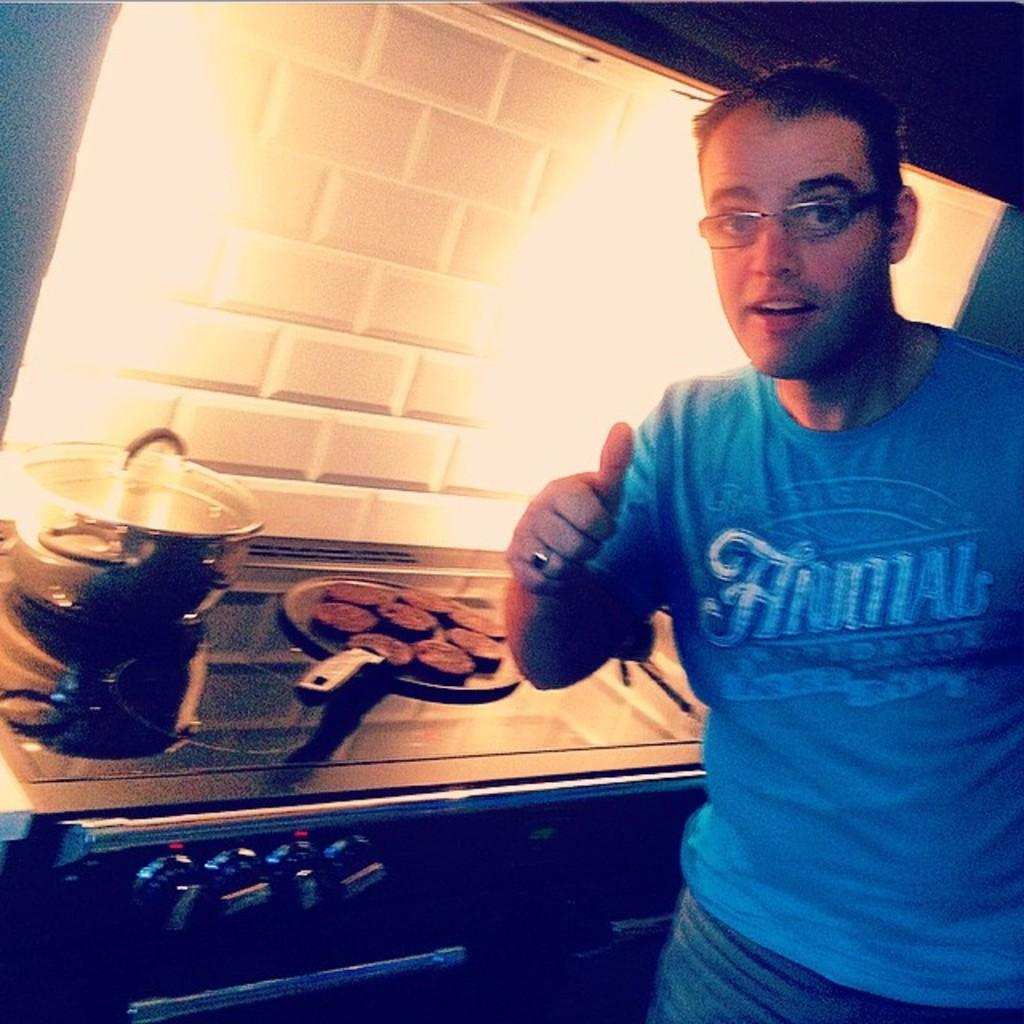<image>
Render a clear and concise summary of the photo. A man standing in a kitchen who is wearing glasses and a blue t-shirt that says Animal on it is giving a thumbs up signal. 